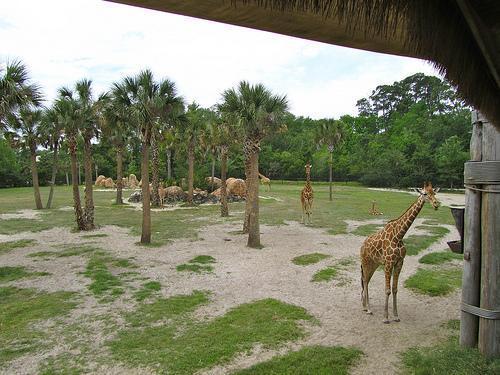How many legs does the giraffe have?
Give a very brief answer. 4. 